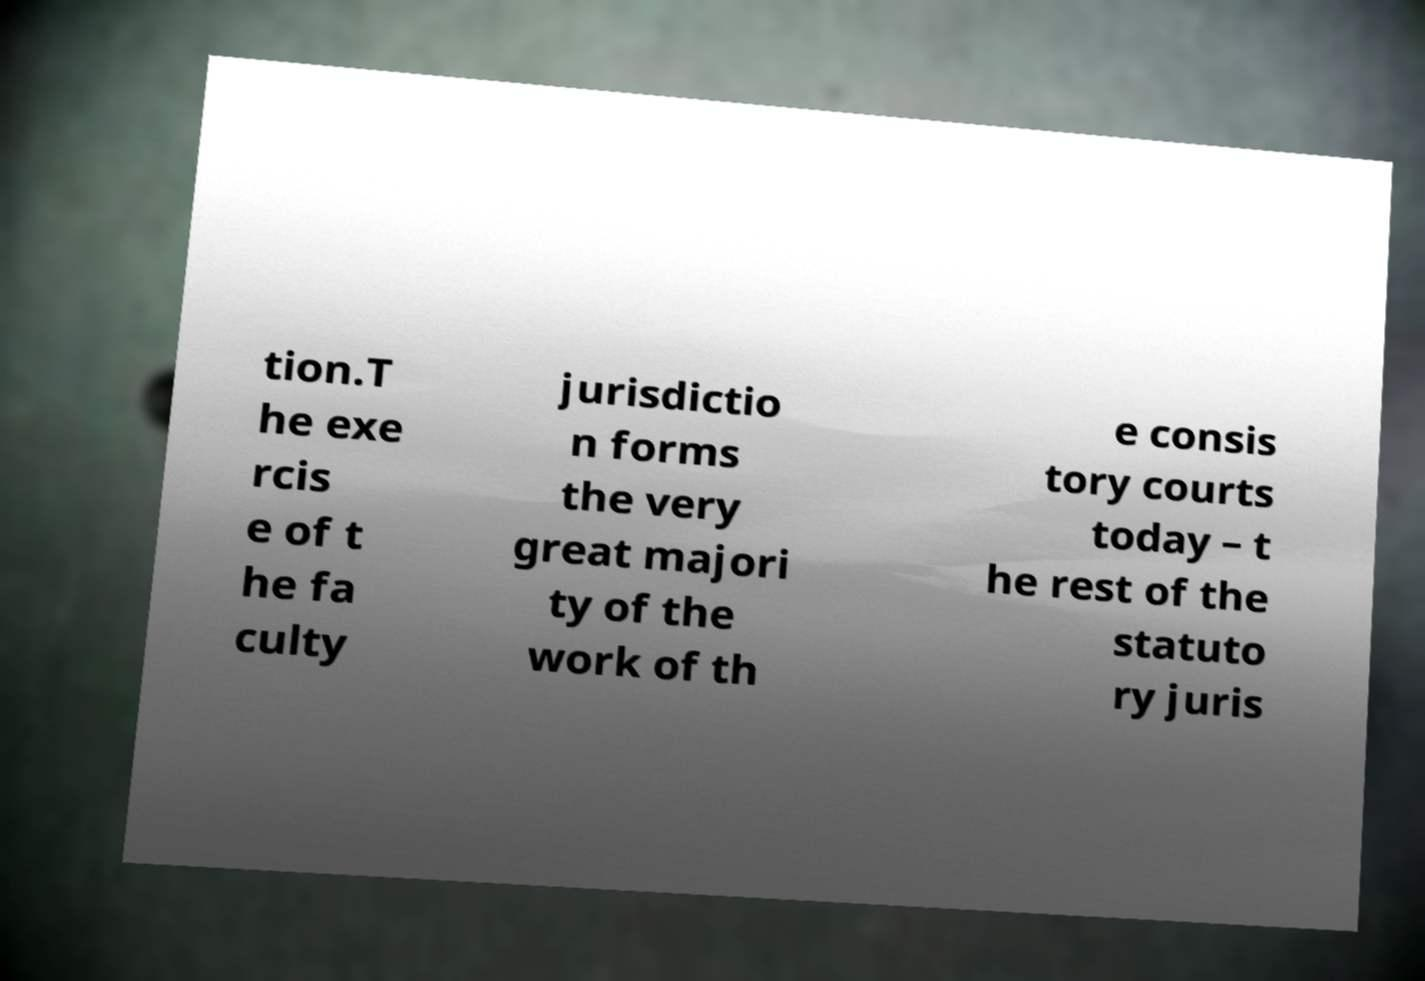Please read and relay the text visible in this image. What does it say? tion.T he exe rcis e of t he fa culty jurisdictio n forms the very great majori ty of the work of th e consis tory courts today – t he rest of the statuto ry juris 